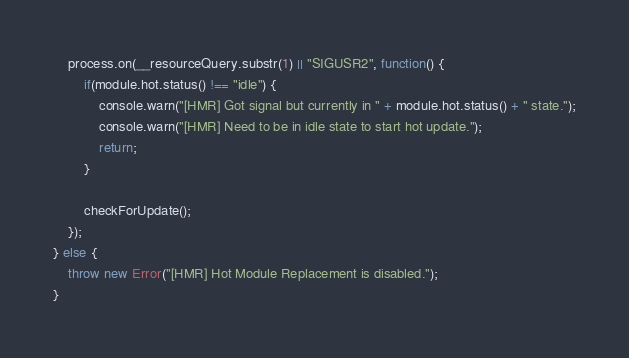<code> <loc_0><loc_0><loc_500><loc_500><_JavaScript_>	process.on(__resourceQuery.substr(1) || "SIGUSR2", function() {
		if(module.hot.status() !== "idle") {
			console.warn("[HMR] Got signal but currently in " + module.hot.status() + " state.");
			console.warn("[HMR] Need to be in idle state to start hot update.");
			return;
		}

		checkForUpdate();
	});
} else {
	throw new Error("[HMR] Hot Module Replacement is disabled.");
}
</code> 